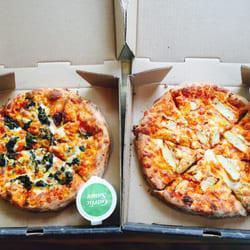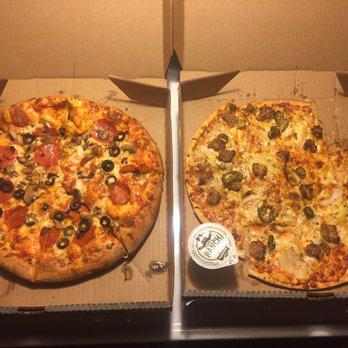The first image is the image on the left, the second image is the image on the right. Evaluate the accuracy of this statement regarding the images: "One image has melted cheese stretched out between two pieces of food, and the other has a whole pizza.". Is it true? Answer yes or no. No. The first image is the image on the left, the second image is the image on the right. Assess this claim about the two images: "There is a total of two circle pizzas.". Correct or not? Answer yes or no. No. 